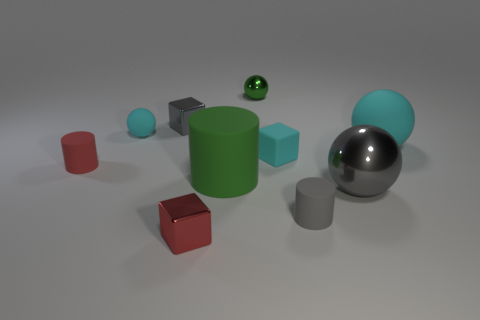What size is the gray thing that is the same shape as the green shiny object?
Offer a very short reply. Large. Does the small shiny sphere have the same color as the large metallic sphere?
Your answer should be compact. No. How many gray metallic cubes are on the right side of the rubber ball that is right of the shiny ball to the right of the gray matte object?
Offer a terse response. 0. Are there more gray cubes than small purple objects?
Give a very brief answer. Yes. How many small gray metallic objects are there?
Make the answer very short. 1. There is a large rubber object that is to the left of the tiny green metal sphere that is behind the rubber sphere that is right of the small green metal ball; what shape is it?
Offer a very short reply. Cylinder. Are there fewer big green cylinders that are right of the green rubber object than cyan spheres left of the green shiny object?
Your response must be concise. Yes. There is a large matte thing that is in front of the big cyan matte object; does it have the same shape as the object that is to the left of the tiny cyan ball?
Offer a terse response. Yes. The big green thing that is right of the gray object that is behind the big gray ball is what shape?
Provide a succinct answer. Cylinder. What size is the cylinder that is the same color as the large shiny object?
Your answer should be very brief. Small. 